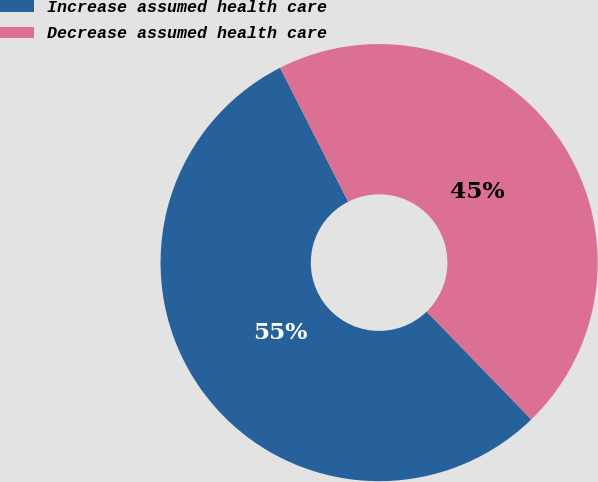<chart> <loc_0><loc_0><loc_500><loc_500><pie_chart><fcel>Increase assumed health care<fcel>Decrease assumed health care<nl><fcel>54.78%<fcel>45.22%<nl></chart> 